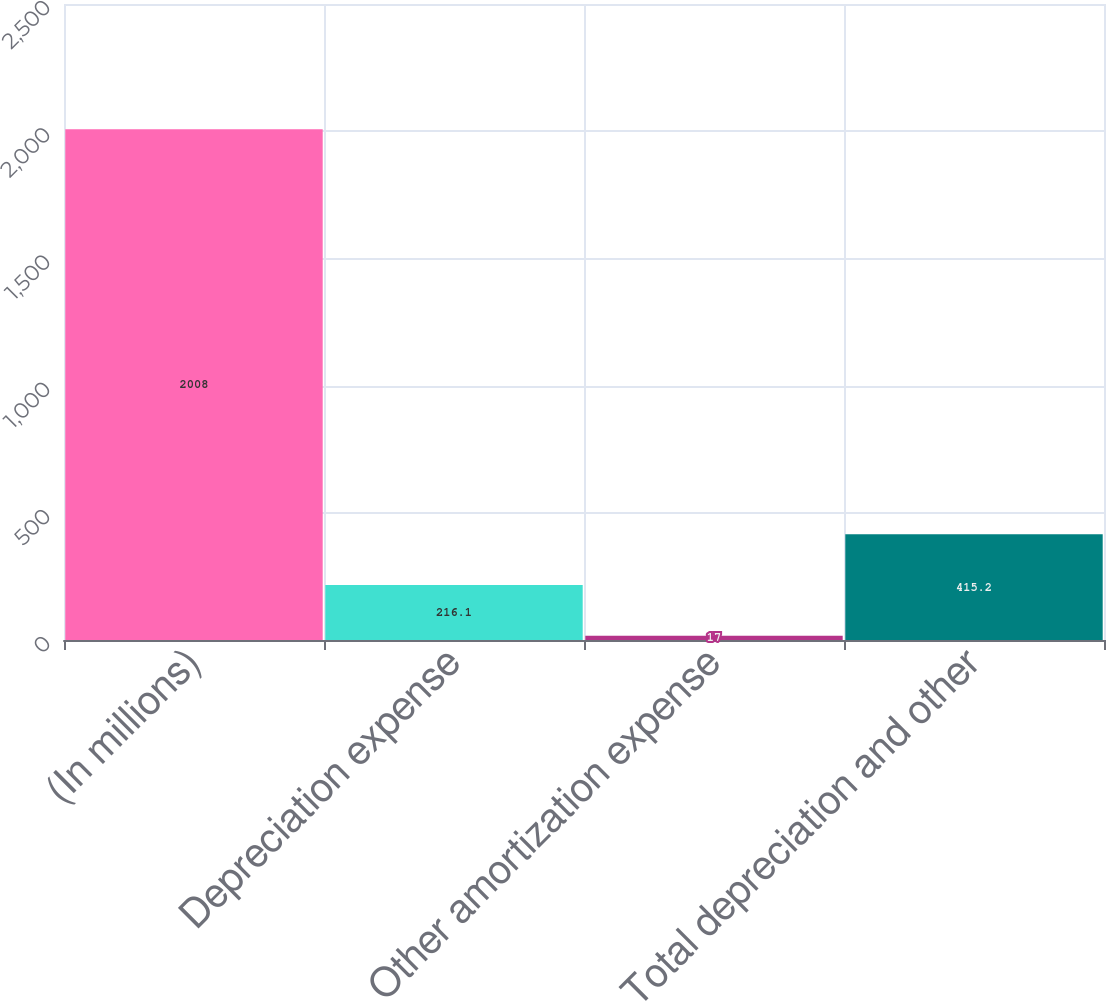<chart> <loc_0><loc_0><loc_500><loc_500><bar_chart><fcel>(In millions)<fcel>Depreciation expense<fcel>Other amortization expense<fcel>Total depreciation and other<nl><fcel>2008<fcel>216.1<fcel>17<fcel>415.2<nl></chart> 